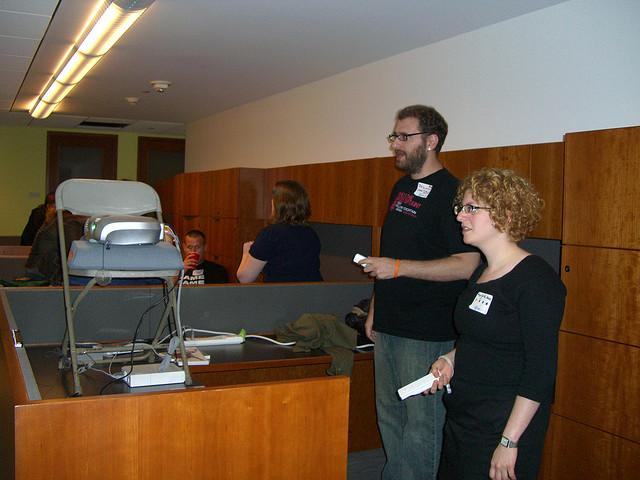What kind of label is on their shirts? name 